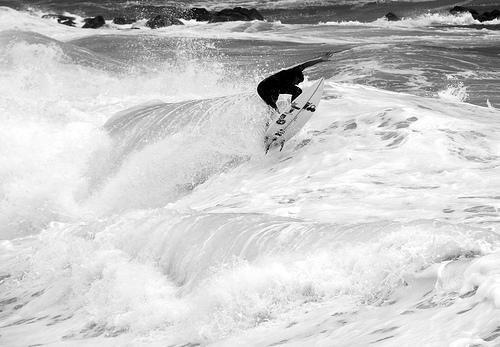How many people are in the photo?
Give a very brief answer. 1. 